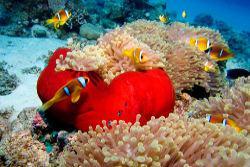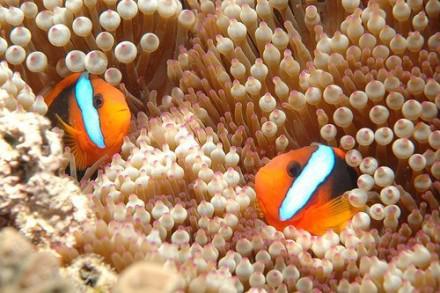The first image is the image on the left, the second image is the image on the right. For the images displayed, is the sentence "In at least one image there is a single clownfish swimming right forward through arms of corral." factually correct? Answer yes or no. No. The first image is the image on the left, the second image is the image on the right. Considering the images on both sides, is "One image shows exactly one clownfish, which is angled facing rightward above pale anemone tendrils, and the other image includes two clownfish with three stripes each visible in the foreground swimming by pale anemone tendrils." valid? Answer yes or no. No. 